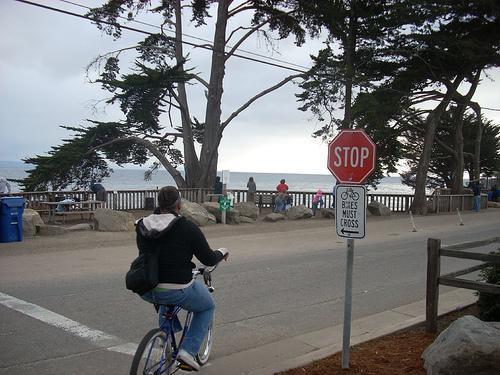How many wheels are in this picture?
Give a very brief answer. 2. How many trees are there?
Give a very brief answer. 5. How many stop signs are there?
Give a very brief answer. 1. 